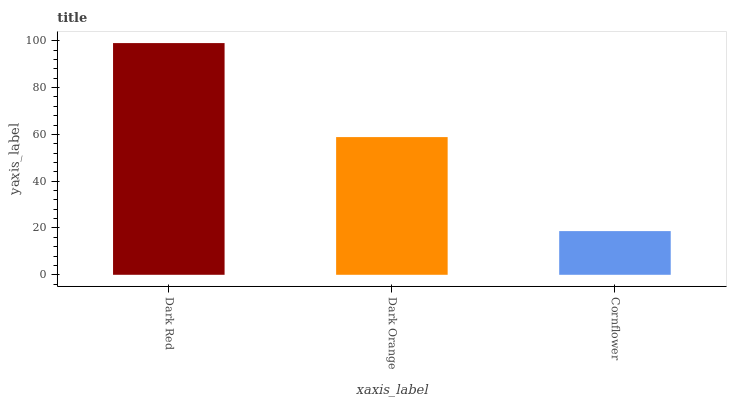Is Cornflower the minimum?
Answer yes or no. Yes. Is Dark Red the maximum?
Answer yes or no. Yes. Is Dark Orange the minimum?
Answer yes or no. No. Is Dark Orange the maximum?
Answer yes or no. No. Is Dark Red greater than Dark Orange?
Answer yes or no. Yes. Is Dark Orange less than Dark Red?
Answer yes or no. Yes. Is Dark Orange greater than Dark Red?
Answer yes or no. No. Is Dark Red less than Dark Orange?
Answer yes or no. No. Is Dark Orange the high median?
Answer yes or no. Yes. Is Dark Orange the low median?
Answer yes or no. Yes. Is Dark Red the high median?
Answer yes or no. No. Is Cornflower the low median?
Answer yes or no. No. 